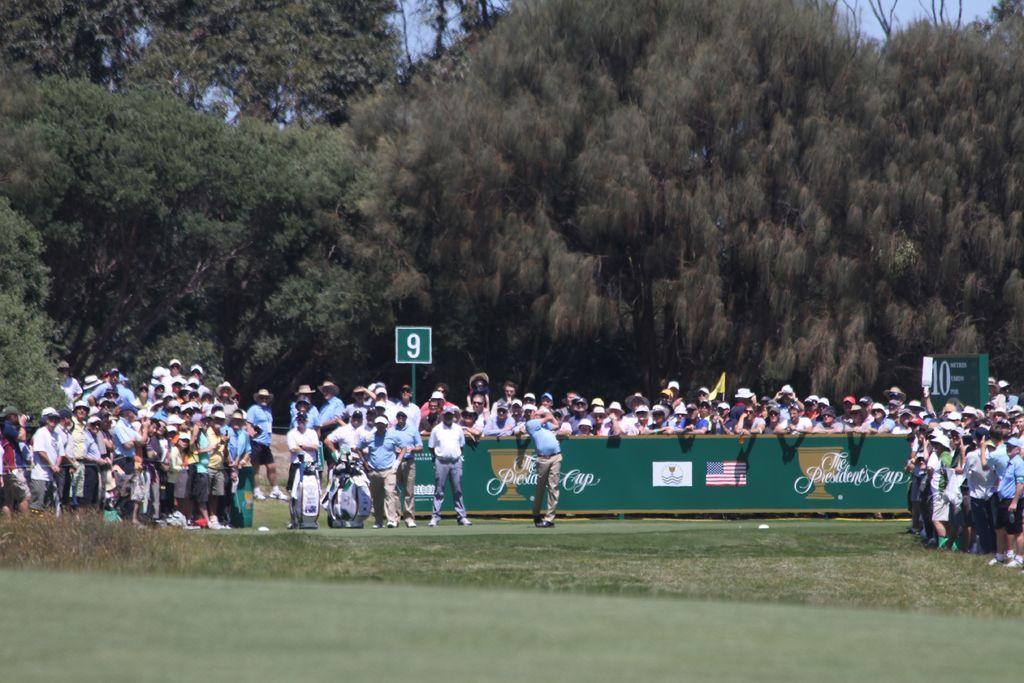How would you summarize this image in a sentence or two? In this image I can see a group of people standing in the center of the image. I can see a board with some text and flags in front of a few people. I can see some sign boards. At the top of the image I can see the trees. At the bottom of the image I can see the grass. 